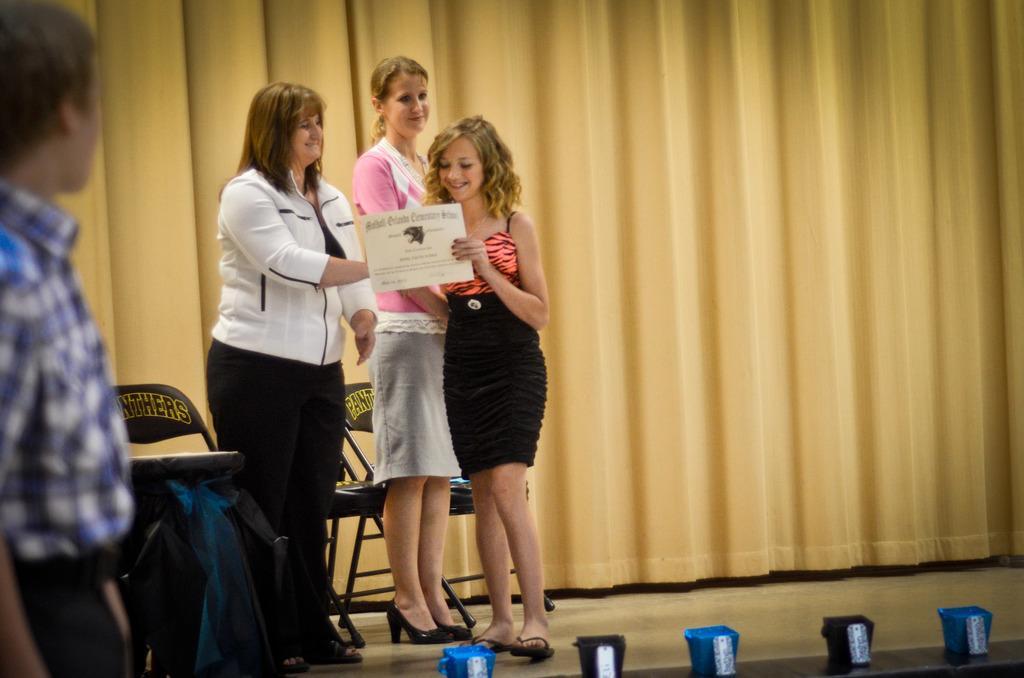Can you describe this image briefly? In this image there is a woman and two girls, behind them there are three chairs and a curtain, left side a man standing. 